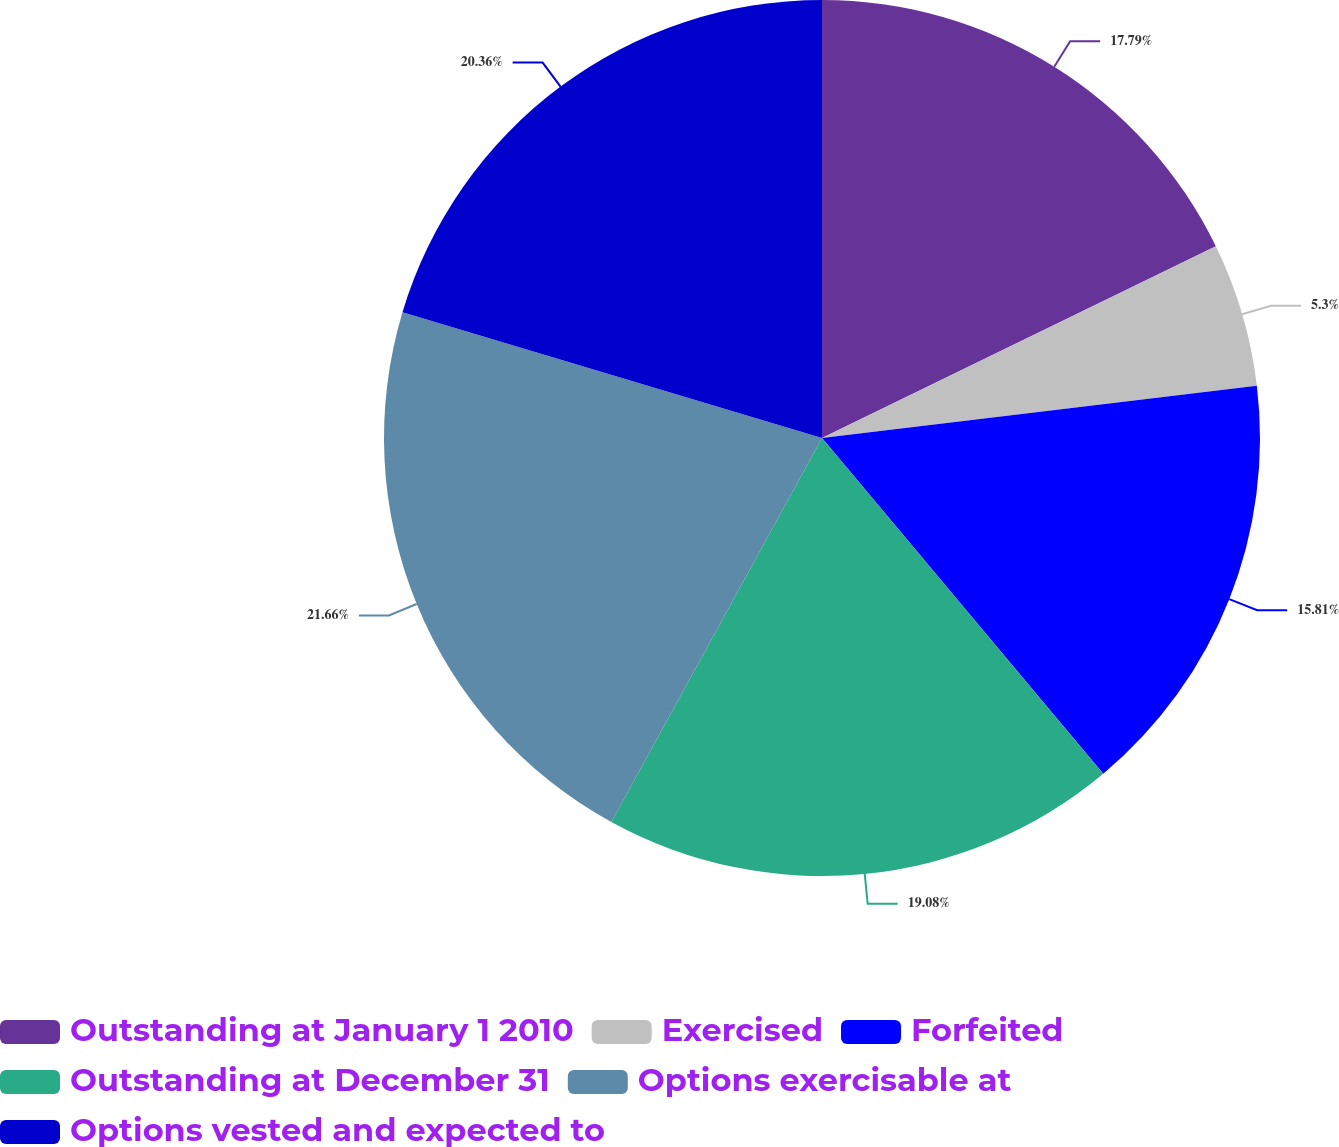<chart> <loc_0><loc_0><loc_500><loc_500><pie_chart><fcel>Outstanding at January 1 2010<fcel>Exercised<fcel>Forfeited<fcel>Outstanding at December 31<fcel>Options exercisable at<fcel>Options vested and expected to<nl><fcel>17.79%<fcel>5.3%<fcel>15.81%<fcel>19.08%<fcel>21.65%<fcel>20.36%<nl></chart> 